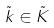Convert formula to latex. <formula><loc_0><loc_0><loc_500><loc_500>\tilde { k } \in \tilde { K }</formula> 